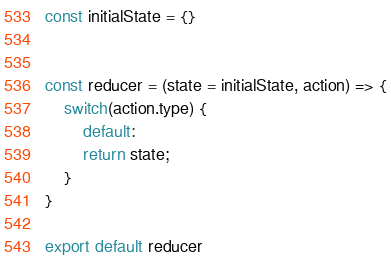Convert code to text. <code><loc_0><loc_0><loc_500><loc_500><_JavaScript_>const initialState = {}


const reducer = (state = initialState, action) => {
    switch(action.type) {
        default: 
        return state;
    }
}

export default reducer</code> 